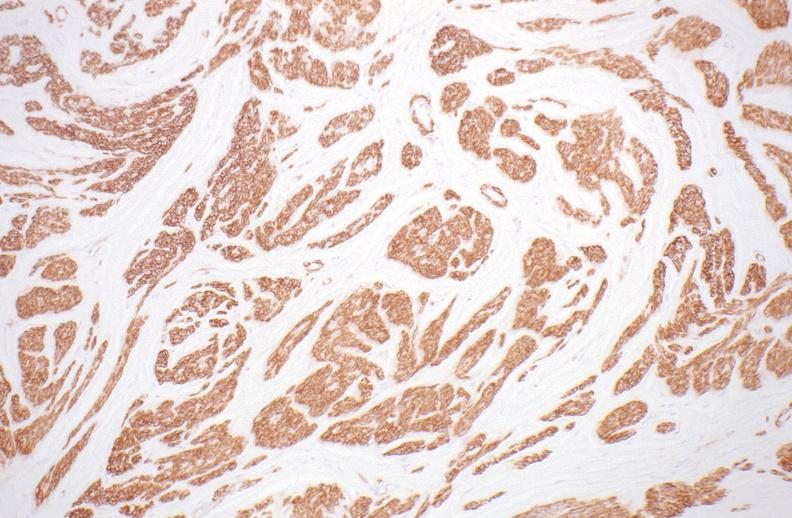s peritoneum present?
Answer the question using a single word or phrase. No 